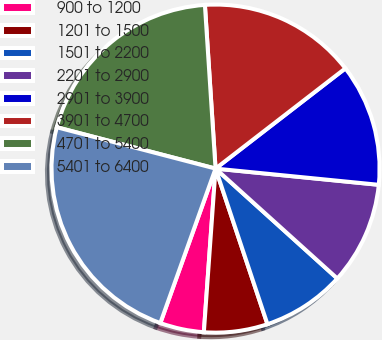Convert chart. <chart><loc_0><loc_0><loc_500><loc_500><pie_chart><fcel>900 to 1200<fcel>1201 to 1500<fcel>1501 to 2200<fcel>2201 to 2900<fcel>2901 to 3900<fcel>3901 to 4700<fcel>4701 to 5400<fcel>5401 to 6400<nl><fcel>4.33%<fcel>6.26%<fcel>8.19%<fcel>10.11%<fcel>12.04%<fcel>15.57%<fcel>19.91%<fcel>23.59%<nl></chart> 